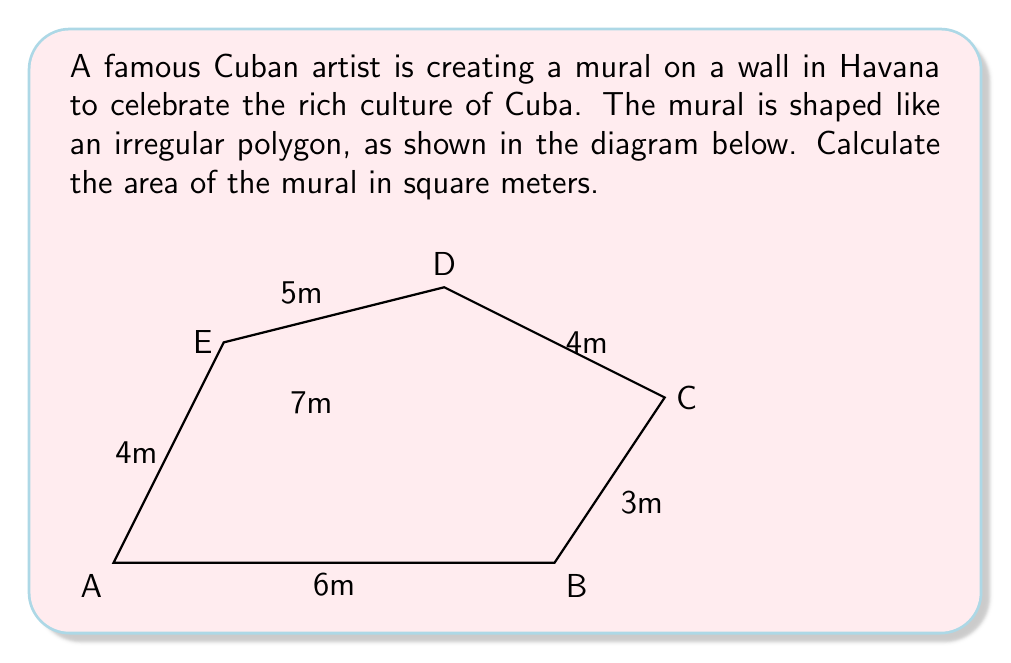Show me your answer to this math problem. To calculate the area of this irregular polygon, we can divide it into triangles and use the formula for the area of a triangle: $A = \frac{1}{2}bh$.

Let's divide the polygon into three triangles: ABD, BCD, and ADE.

1. Triangle ABD:
   Base = 6m, Height = 5m
   Area of ABD = $\frac{1}{2} \times 6 \times 5 = 15$ sq m

2. Triangle BCD:
   We can find the height using the Pythagorean theorem:
   $h^2 = 3^2 + 2^2 = 13$
   $h = \sqrt{13}$ m
   Area of BCD = $\frac{1}{2} \times 4 \times \sqrt{13}$ sq m

3. Triangle ADE:
   Base = 4m, Height = 4m
   Area of ADE = $\frac{1}{2} \times 4 \times 4 = 8$ sq m

Total area = Area of ABD + Area of BCD + Area of ADE
$$A_{total} = 15 + 2\sqrt{13} + 8 = 23 + 2\sqrt{13}$$ sq m
Answer: The area of the mural is $(23 + 2\sqrt{13})$ square meters. 